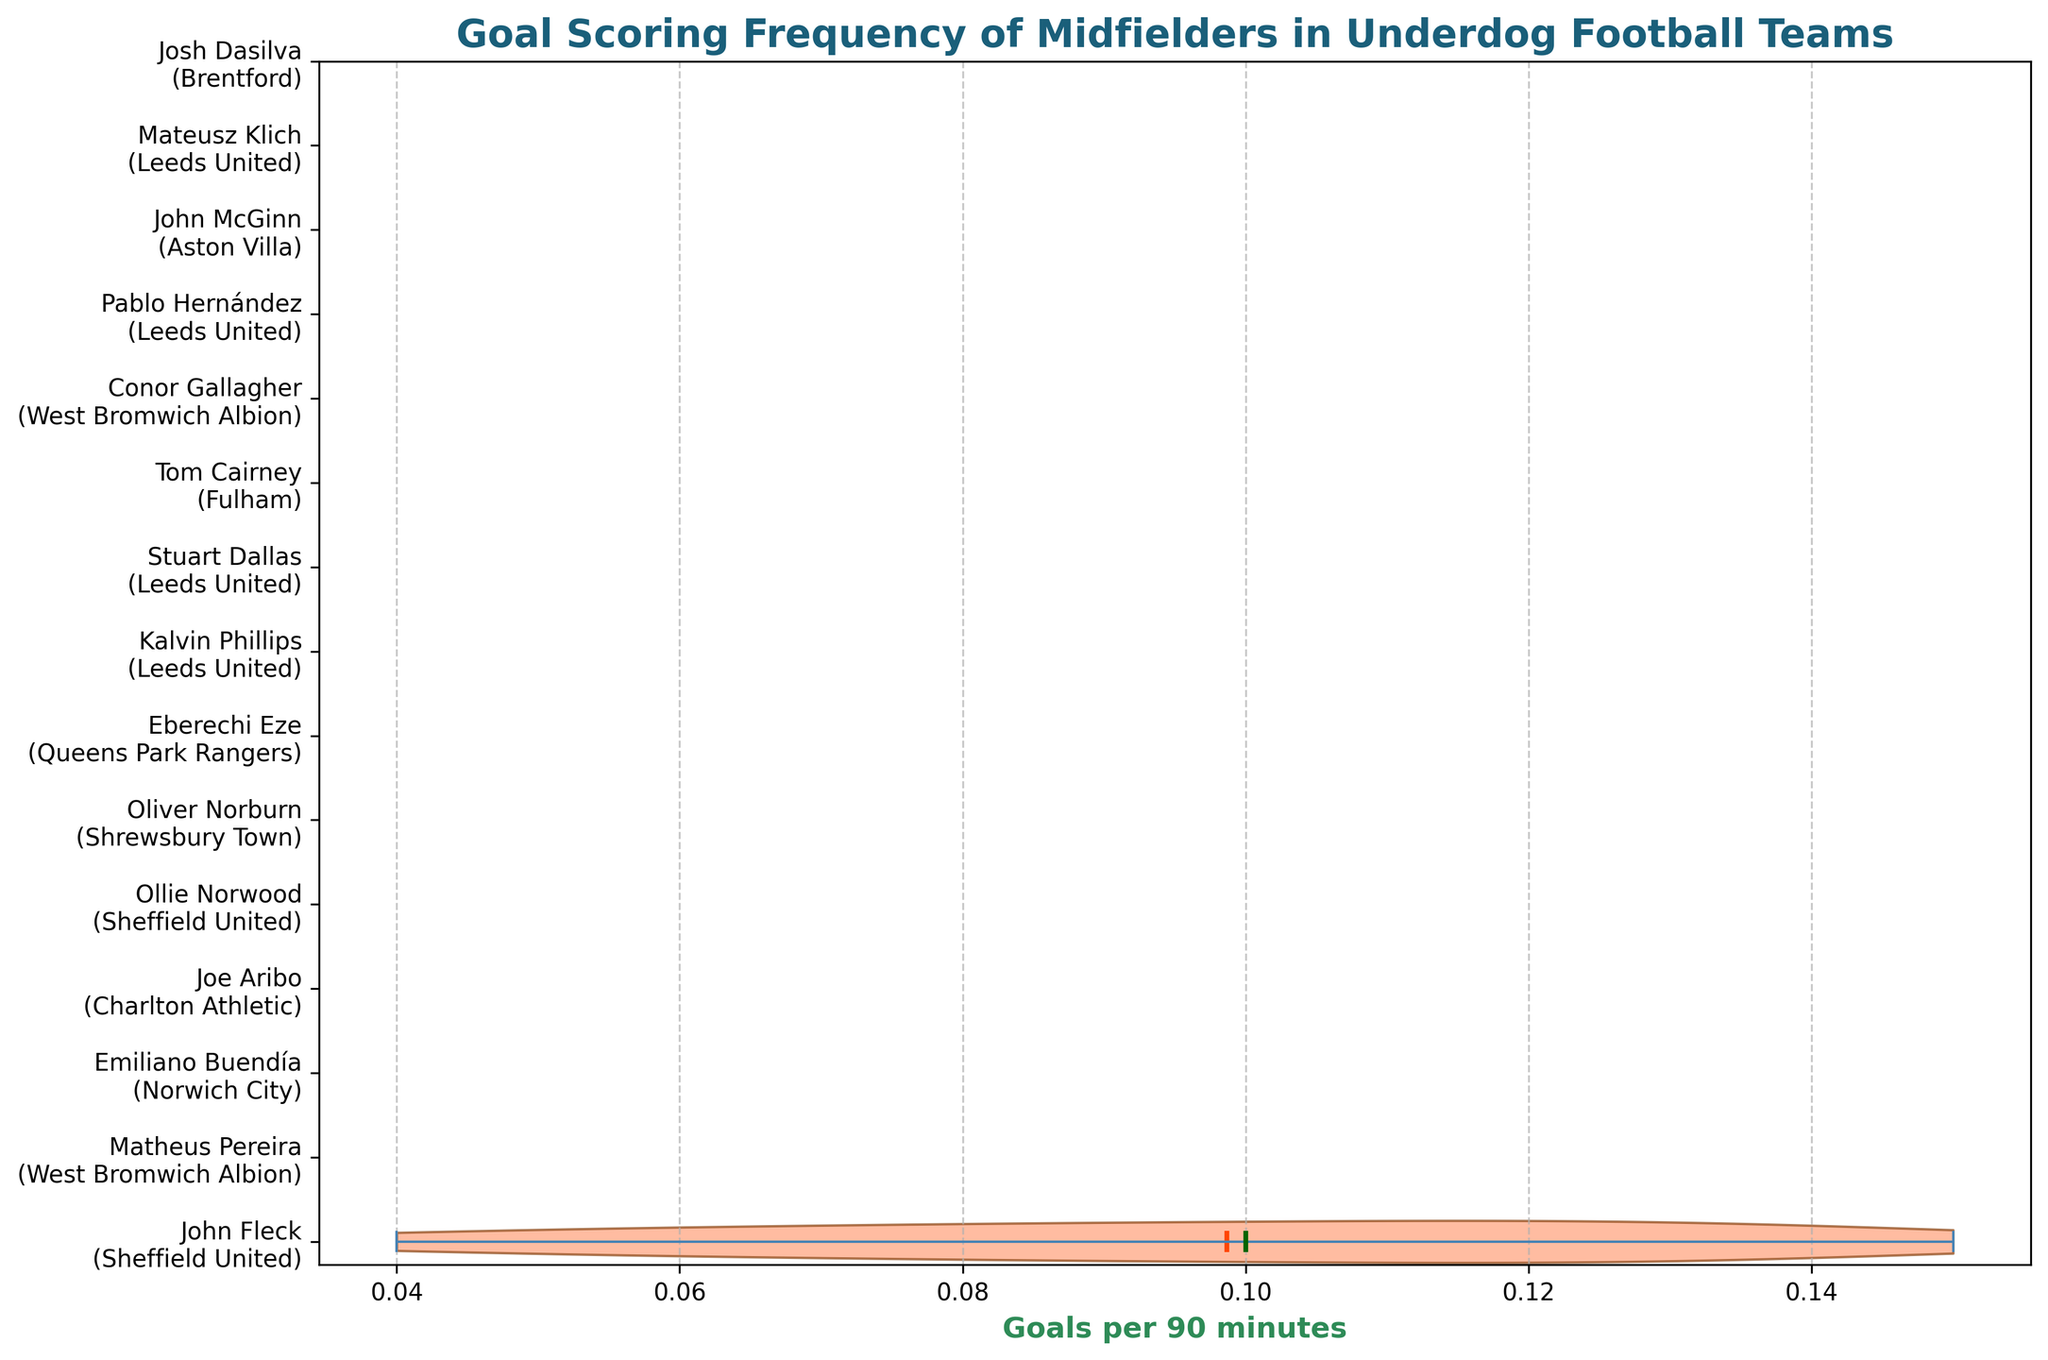Which player has the highest goal scoring frequency? To determine the highest goal scoring frequency, look at the extreme right of the horizontal violin plot. The player with the furthest right mean value is indicated.
Answer: Emiliano Buendía What is the mean goal scoring frequency across all players? In a violin plot, the mean value is typically indicated by a specific marker. Locate the mean marker and find its corresponding value on the x-axis.
Answer: 0.10 goals per 90 minutes Which team has the lowest median goal scoring frequency for its players? Identify the median markers on the horizontal violin plot. The team with the lowest median value can be seen on the leftmost position of the medians.
Answer: Leeds United How does the goal scoring frequency of Tom Cairney compare to Joe Aribo? Compare the positions of Tom Cairney and Joe Aribo on the x-axis where their mean values are marked. Tom Cairney's mean value is further right than Joe Aribo's.
Answer: Tom Cairney has a higher goal scoring frequency than Joe Aribo What is the range of goal scoring frequencies for Oliver Norburn? Identify the extremities of Oliver Norburn's violin plot. The range is the difference between these two values.
Answer: 0.05 goals per 90 minutes Which player from Sheffield United has a higher goal scoring frequency? Compare the mean markers for John Fleck and Ollie Norwood, both from Sheffield United. The player whose mean marker is further right has the higher frequency.
Answer: John Fleck Is there a noticeable difference in goal scoring frequency among players from Leeds United and West Bromwich Albion? Assess the mean and median values for players from Leeds United (Kalvin Phillips, Stuart Dallas, Pablo Hernández, Mateusz Klich) and West Bromwich Albion (Matheus Pereira, Conor Gallagher). Note if one team's players consistently score higher.
Answer: Yes, players from West Bromwich Albion have a higher goal scoring frequency overall What does the shape of the violin plot tell us about Eberechi Eze's goal scoring frequency distribution? Examine the width and shape of Eberechi Eze's violin plot. A wider plot suggests more variability in data, and specific bulges represent the density of values.
Answer: Eberechi Eze's plot shows moderate variability with a dense middle Which position holds the widest spread of goal scoring frequencies: higher or lower frequencies? Analyze the width of the violin plots' extremities. A wider spread at higher frequencies indicates more variability.
Answer: Lower frequencies What insight can be drawn from the comparison of medians for John McGinn and Mateusz Klich? Compare the median markers for John McGinn and Mateusz Klich. The median tells us the middle value when data points are sorted, offering insights into consistency.
Answer: John McGinn has a higher median than Mateusz Klich 